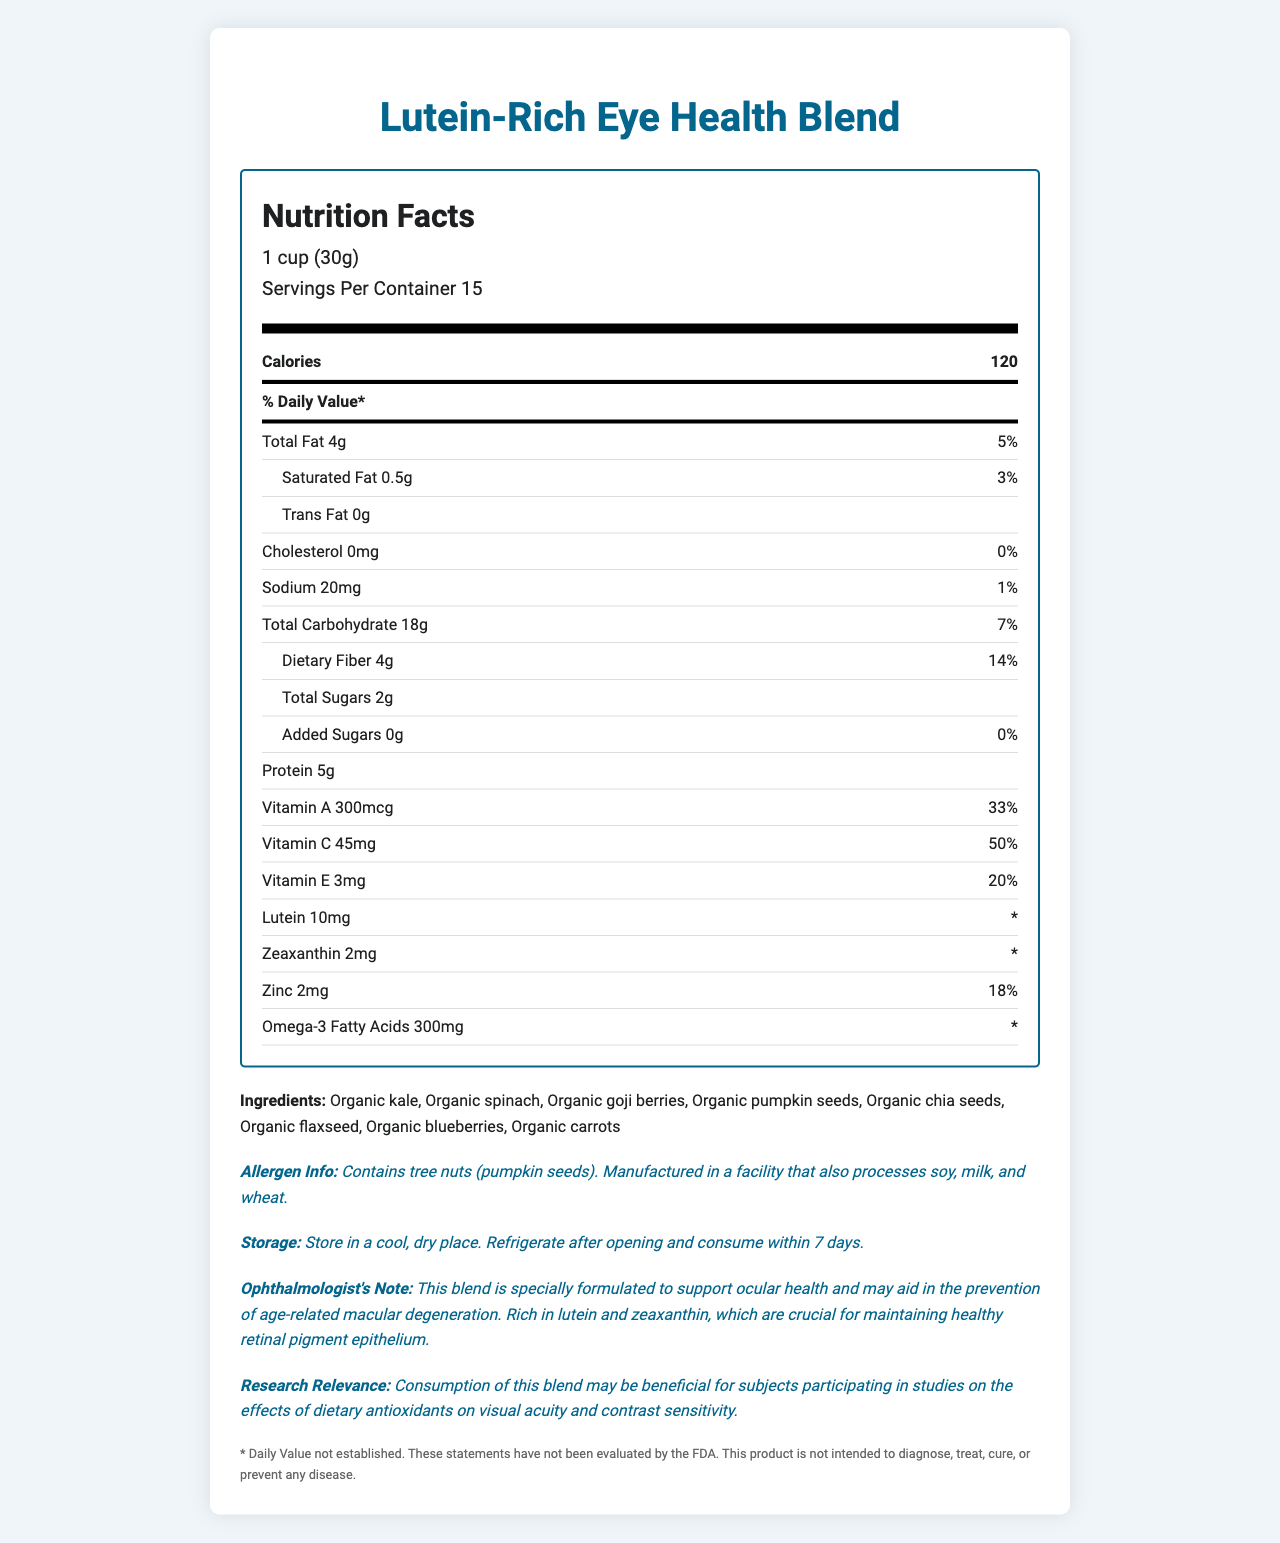what is the serving size of the "Lutein-Rich Eye Health Blend"? The document states that the serving size is "1 cup (30g)".
Answer: 1 cup (30g) how many servings are there in the container? The document mentions "Servings Per Container 15".
Answer: 15 what is the total fat content per serving? The document lists "Total Fat 4g".
Answer: 4g how much lutein is present per serving? The document specifies "Lutein 10mg".
Answer: 10mg which ingredient is known for its high omega-3 fatty acid content? Among the listed ingredients, chia seeds are known for their high omega-3 fatty acid content.
Answer: Organic chia seeds what is the daily value percentage of vitamin C? A. 33% B. 50% C. 20% D. 18% The document states "Vitamin C 50%" in the daily value section.
Answer: B which of the following ingredients is an allergen in this product? A. Soy B. Milk C. Pumpkin seeds D. Wheat The document's allergen information mentions "Contains tree nuts (pumpkin seeds)".
Answer: C is the amount of trans fat in this product significant? The document states "Trans Fat 0g", indicating no trans fat content.
Answer: No summarize the main function of this product. The document describes the product's primary function focusing on eye health, particularly in relation to age-related macular degeneration, due to its high content of eye-friendly antioxidants.
Answer: The product, "Lutein-Rich Eye Health Blend", is designed to support ocular health, particularly in preventing age-related macular degeneration. It is rich in antioxidants, including lutein and zeaxanthin, which are essential for maintaining healthy retinal pigment epithelium. can this product be used to diagnose, treat, cure, or prevent any disease? The disclaimer on the document states that the product is not intended to diagnose, treat, cure, or prevent any disease.
Answer: No what is the protein content per serving? The document lists "Protein 5g".
Answer: 5g what is the daily value percentage of zinc? The document specifies "Zinc 18%".
Answer: 18% how should the product be stored after opening? The storage instructions mention refrigerating after opening and consuming within 7 days.
Answer: Refrigerate and consume within 7 days does the product contain any added sugars? The document states "Added Sugars 0g".
Answer: No are there any manufacturing cross-contamination risks mentioned? The document notes that the product is "Manufactured in a facility that also processes soy, milk, and wheat".
Answer: Yes what is the visual acuity improvement claim based on the research relevance? The document mentions that consumption may be beneficial for studies on the effects of dietary antioxidants on visual acuity and contrast sensitivity.
Answer: Dietary antioxidants What is the manufacturing process used for Organic kale? The document does not provide details about the manufacturing process for Organic kale.
Answer: Not enough information 